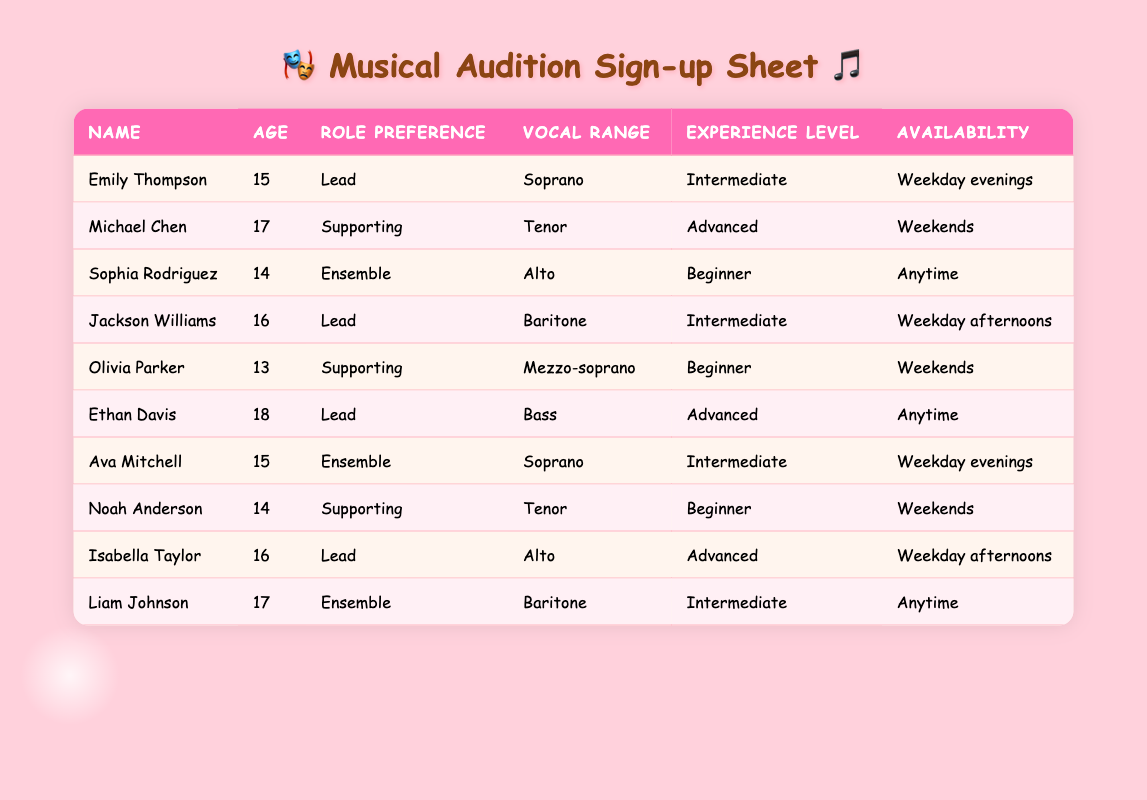What is the vocal range of Emily Thompson? Emily Thompson's vocal range is listed in the table under the Vocal Range column, and it states Soprano.
Answer: Soprano How many participants have a beginner experience level? By counting the entries in the Experience Level column, we find three participants marked as Beginner: Sophia Rodriguez, Olivia Parker, and Noah Anderson.
Answer: 3 What is the average age of participants who prefer a lead role? The ages of participants preferring a lead role are 15 (Emily Thompson), 16 (Jackson Williams), 18 (Ethan Davis), and 16 (Isabella Taylor). Adding them gives 15 + 16 + 18 + 16 = 65, and there are 4 participants, so the average age is 65 / 4, which equals 16.25.
Answer: 16.25 Is there a participant with weekend availability who has an advanced experience level? By reviewing the table, Michael Chen is available on weekends and has an advanced experience level. Thus, the fact is true.
Answer: Yes How many ensemble members are available anytime? Checking the Availability column, we see that only Liam Johnson is an ensemble member and his availability is listed as Anytime. Therefore, the count is one.
Answer: 1 